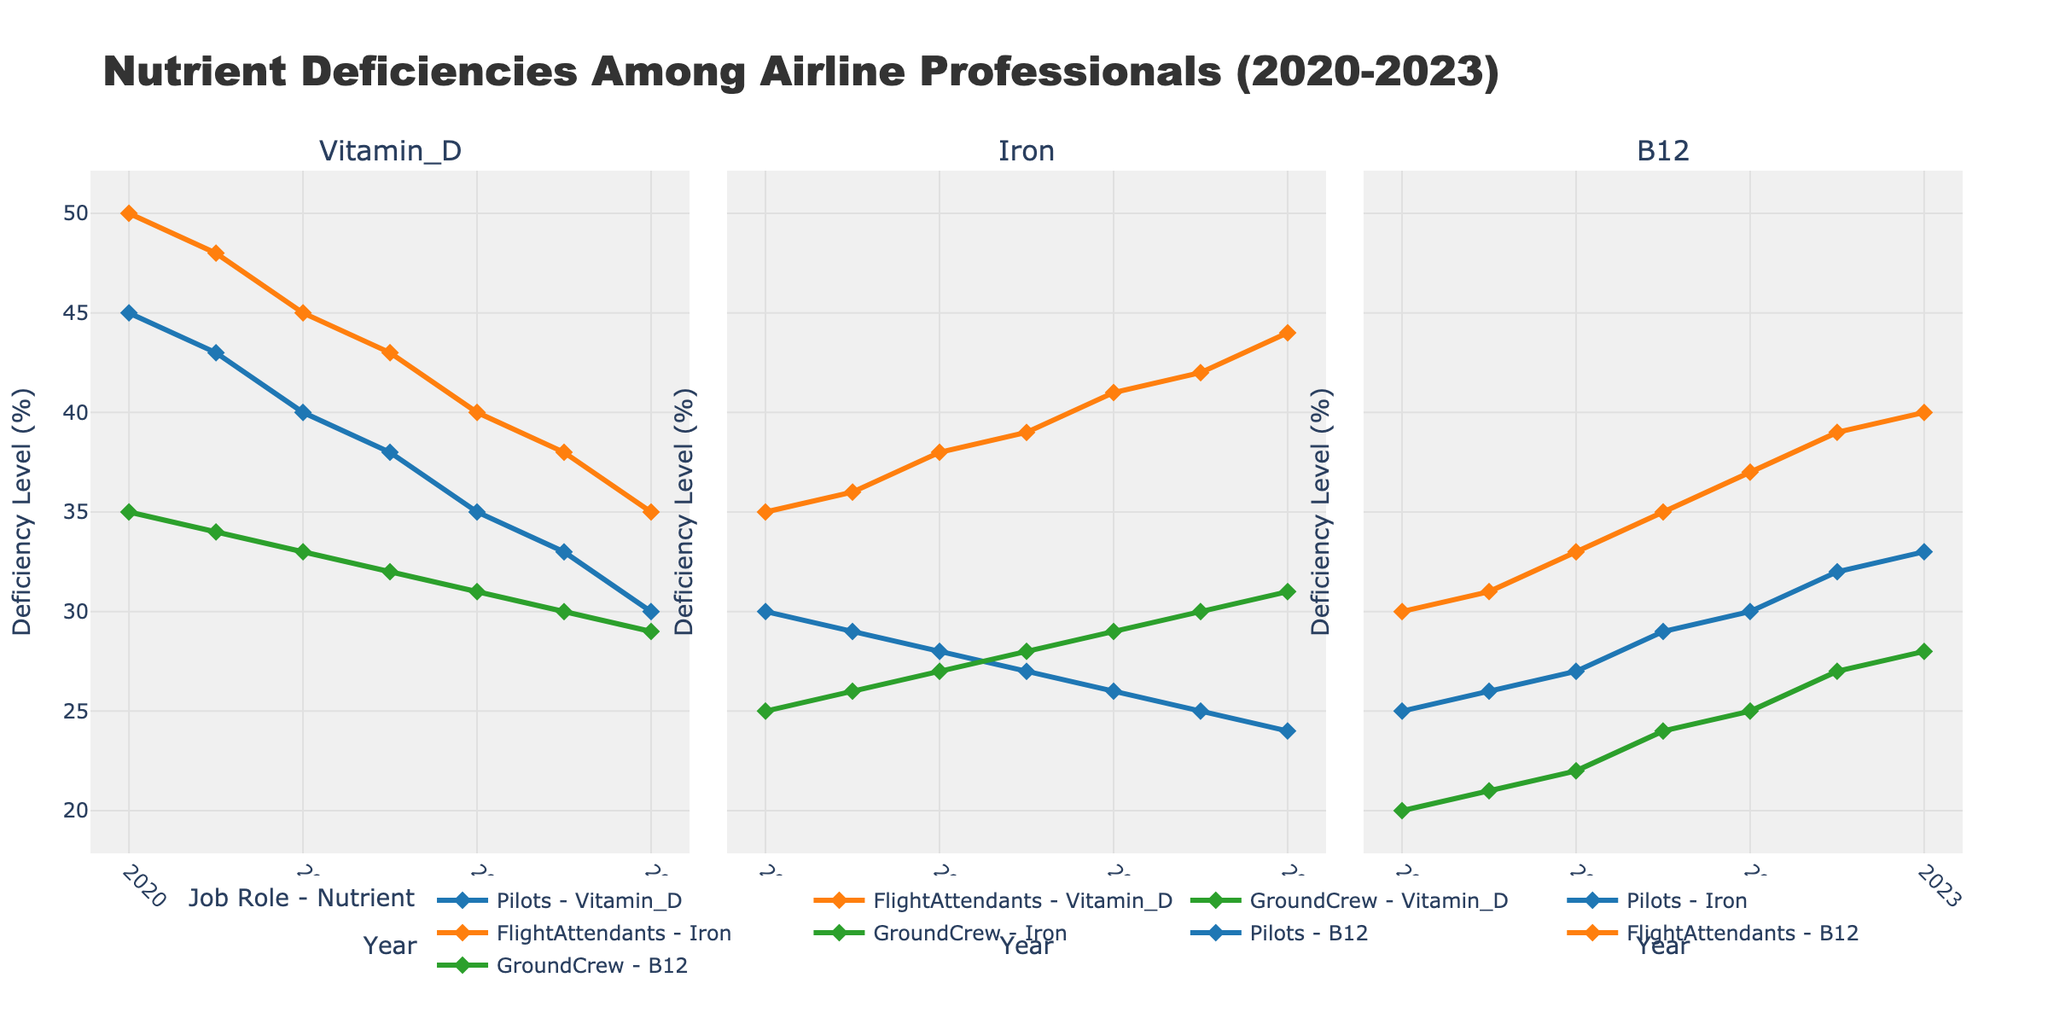What nutrient deficiency saw the greatest decrease among Flight Attendants from 2020 to 2023? Look at the trend lines of Flight Attendants for each nutrient between the years 2020 and 2023. Identify which line has the largest drop. Vitamin D decreases from 50% to 35%, Iron decreases from 35% to 44%, and B12 increases from 30% to 40%. Hence, Vitamin D shows the greatest decrease.
Answer: Vitamin D Which job role experienced the largest change in Iron deficiency over the 3-year timeframe? Examine the lines representing Iron deficiency for each job role from 2020 to 2023. Pilots' Iron deficiency decreased from 30% to 24%, Flight Attendants' Iron deficiency increased from 35% to 44%, and Ground Crew's Iron deficiency increased from 25% to 31%. The largest change is seen in Flight Attendants.
Answer: Flight Attendants Considering the year 2021, did Pilots or Ground Crew have a higher deficiency in Vitamin D? Compare the data points for Vitamin D deficiency between Pilots and Ground Crew in the year 2021. Pilots' deficiency was 40%, whereas Ground Crew's was 33%. Therefore, Pilots had a higher deficiency.
Answer: Pilots What was the combined deficiency level of Vitamin B12 for all job roles in the year 2023? Sum up the values of B12 deficiency for each job role in the year 2023: Pilots (33%), Flight Attendants (40%), and Ground Crew (28%). The combined deficiency is 33 + 40 + 28 = 101%.
Answer: 101% Among Vitamin D, Iron, and B12 deficiencies, which showed a consistent decrease for Pilots? Examine the trend lines for each nutrient deficiency for Pilots and see which one is consistently decreasing over the 3-year period. Vitamin D deficiency decreases from 45% to 30%, Iron deficiency decreases from 30% to 24%, whereas B12 increases from 25% to 33%. Both Vitamin D and Iron show a consistent decrease.
Answer: Vitamin D, Iron Did any job role see an increase in all three nutrient deficiencies from 2020 to 2023? Check the trend lines for each job role across the three nutrients from 2020 to 2023. Flight Attendants show an increase in Iron from 35% to 44% and B12 from 30% to 40%, but a decrease in Vitamin D from 50% to 35%. Pilots show decreases in both Vitamin D and Iron. Ground Crew shows an increase for Iron (25% to 31%) and B12 (20% to 28%), but a decrease in Vitamin D (35% to 29%). No job role shows an increase in all three deficiencies.
Answer: No Among Pilots, what year did Vitamin D and B12 deficiencies converge? Identify the year in which the Pilots' deficiency levels for Vitamin D and B12 were the same. By examining the graph, we see that both Vitamin D and B12 deficiencies were 33% in the year 2023.
Answer: 2023 For Ground Crew in the year 2022, was their Iron deficiency higher or lower than their Vitamin D deficiency? Compare the values of Iron and Vitamin D deficiencies for Ground Crew in the year 2022. Iron deficiency is at 29% and Vitamin D deficiency is at 31%. Iron deficiency was lower than Vitamin D deficiency.
Answer: Lower 